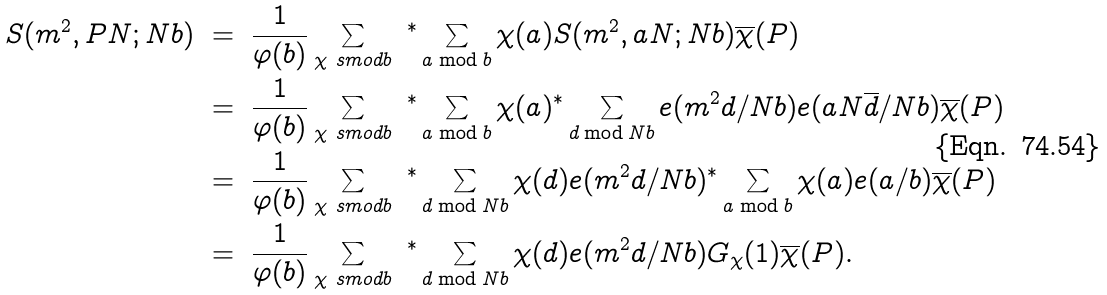<formula> <loc_0><loc_0><loc_500><loc_500>S ( m ^ { 2 } , P N ; N b ) \ & = \ \frac { 1 } { \varphi ( b ) } \sum _ { \chi \ s m o d { b } } \ { ^ { * } } \sum _ { a \bmod b } \chi ( a ) S ( m ^ { 2 } , a N ; N b ) \overline { \chi } ( P ) \\ & = \ \frac { 1 } { \varphi ( b ) } \sum _ { \chi \ s m o d { b } } \ { ^ { * } } \sum _ { a \bmod b } \chi ( a ) { ^ { * } } \sum _ { d \bmod N b } e ( m ^ { 2 } d / N b ) e ( a N \overline { d } / N b ) \overline { \chi } ( P ) \\ & = \ \frac { 1 } { \varphi ( b ) } \sum _ { \chi \ s m o d { b } } \ { ^ { * } } \sum _ { d \bmod N b } \chi ( d ) e ( m ^ { 2 } d / N b ) { ^ { * } } \sum _ { a \bmod b } \chi ( a ) e ( a / b ) \overline { \chi } ( P ) \\ & = \ \frac { 1 } { \varphi ( b ) } \sum _ { \chi \ s m o d { b } } \ { ^ { * } } \sum _ { d \bmod N b } \chi ( d ) e ( m ^ { 2 } d / N b ) G _ { \chi } ( 1 ) \overline { \chi } ( P ) .</formula> 